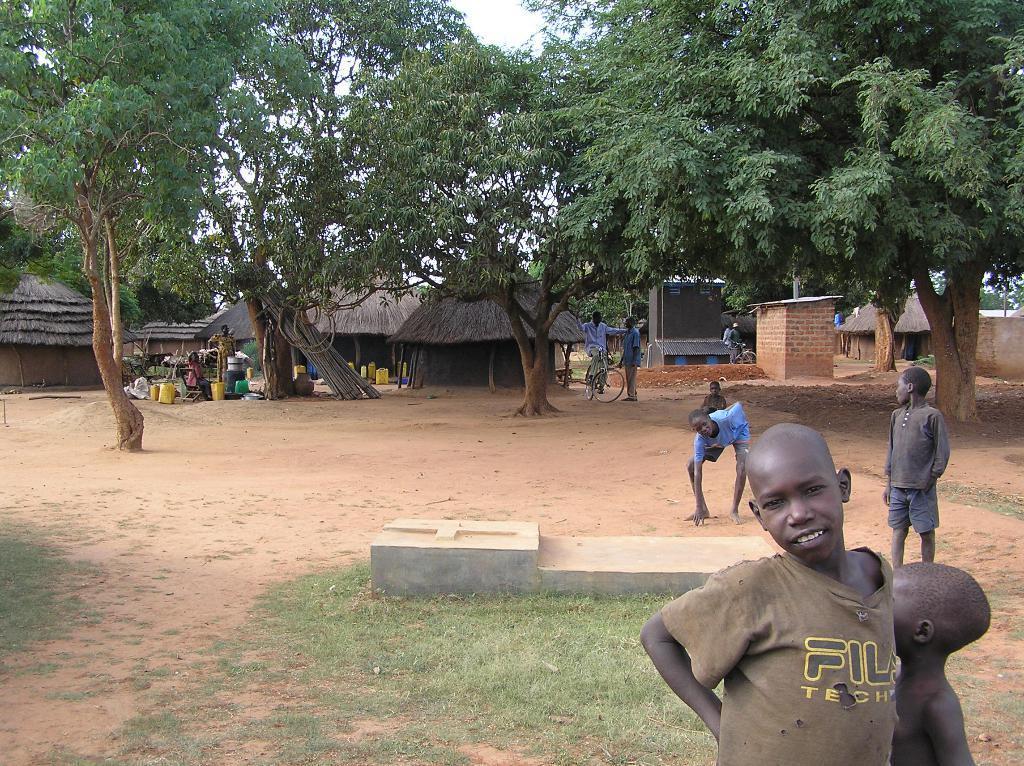Please provide a concise description of this image. In this picture we can see group of people and few trees, in the background we can find few huts and bicycles. 